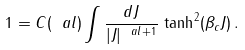<formula> <loc_0><loc_0><loc_500><loc_500>1 = C ( \ a l ) \int \frac { d J } { | J | ^ { \ a l + 1 } } \, \tanh ^ { 2 } ( \beta _ { c } J ) \, .</formula> 